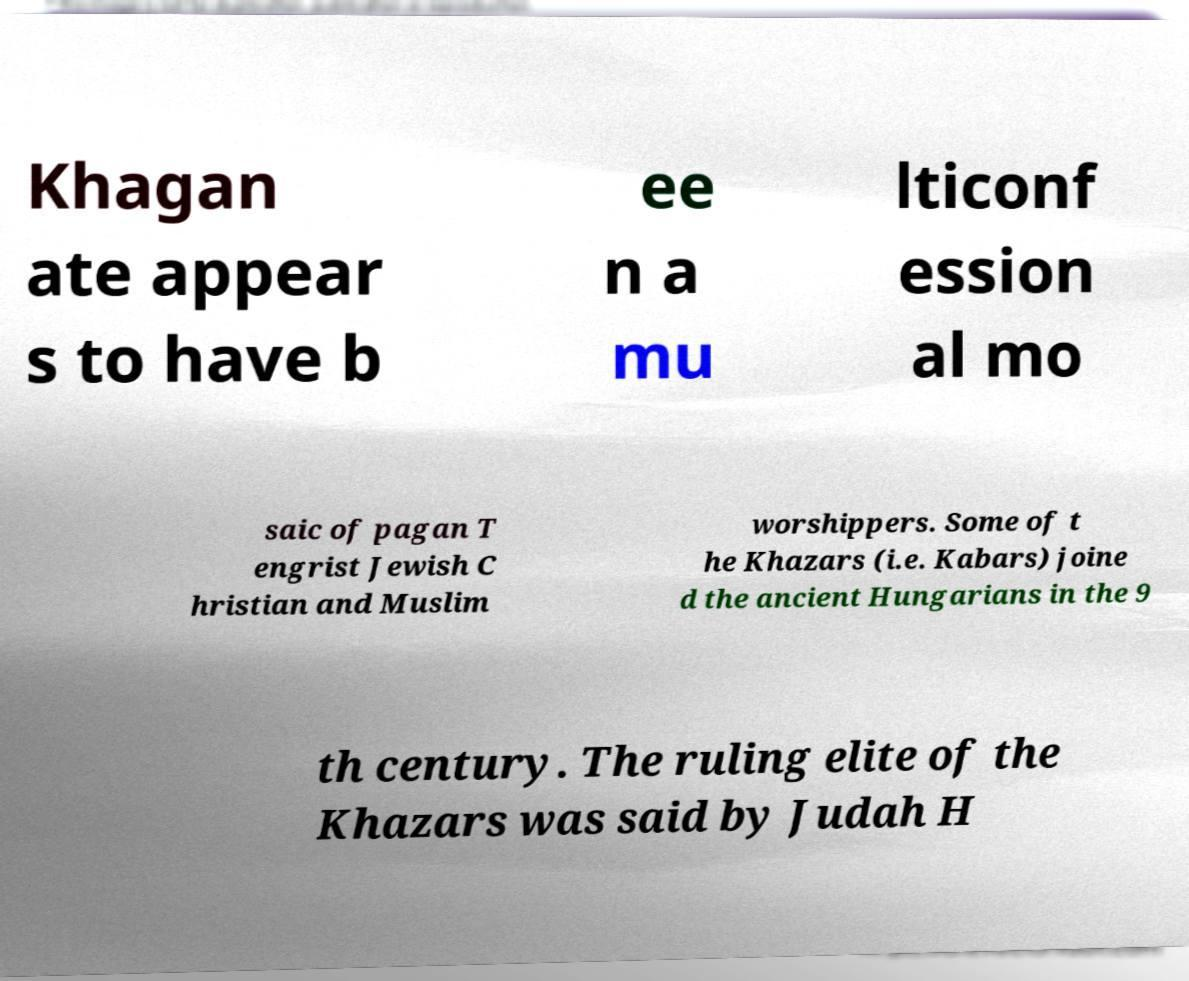Please identify and transcribe the text found in this image. Khagan ate appear s to have b ee n a mu lticonf ession al mo saic of pagan T engrist Jewish C hristian and Muslim worshippers. Some of t he Khazars (i.e. Kabars) joine d the ancient Hungarians in the 9 th century. The ruling elite of the Khazars was said by Judah H 